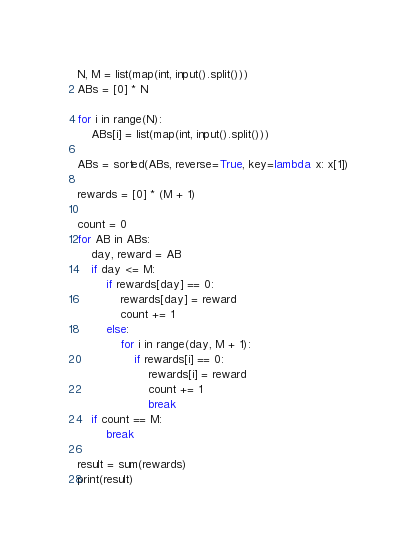Convert code to text. <code><loc_0><loc_0><loc_500><loc_500><_Python_>N, M = list(map(int, input().split()))
ABs = [0] * N

for i in range(N):
    ABs[i] = list(map(int, input().split()))

ABs = sorted(ABs, reverse=True, key=lambda x: x[1])

rewards = [0] * (M + 1)

count = 0
for AB in ABs:
    day, reward = AB
    if day <= M:
        if rewards[day] == 0:
            rewards[day] = reward
            count += 1
        else:
            for i in range(day, M + 1):
                if rewards[i] == 0:
                    rewards[i] = reward
                    count += 1
                    break
    if count == M:
        break

result = sum(rewards)
print(result)</code> 